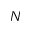Convert formula to latex. <formula><loc_0><loc_0><loc_500><loc_500>N</formula> 